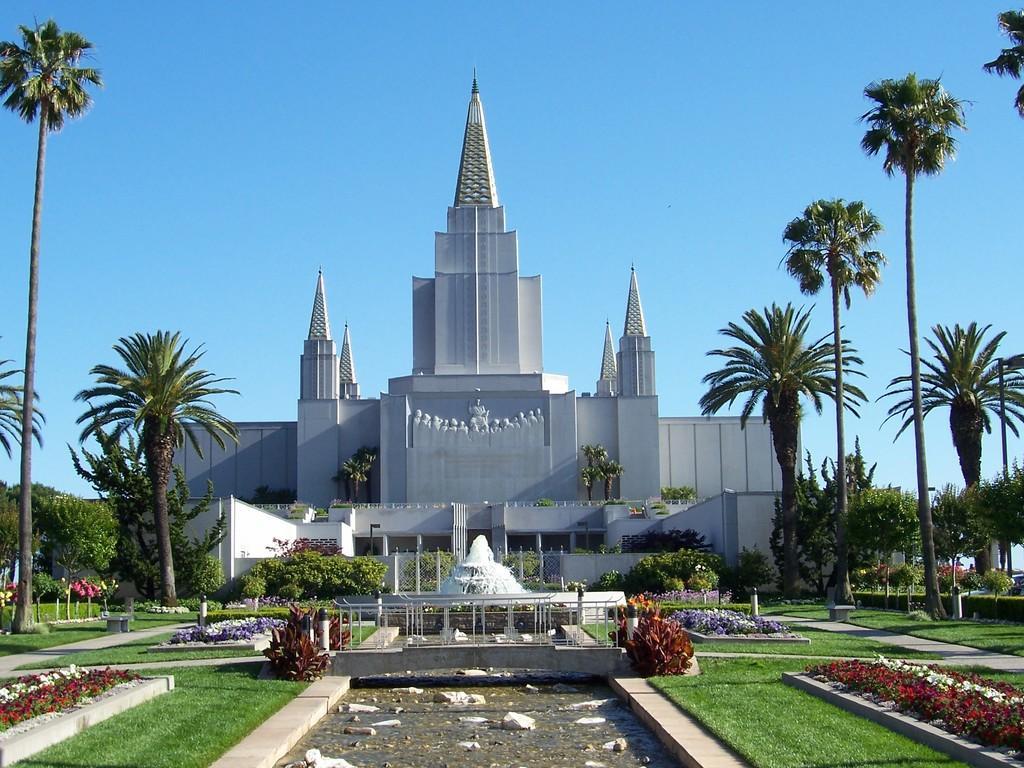Could you give a brief overview of what you see in this image? There is a building. In front of the building there is a fountain. Near to the building there are trees, grass lawn and flowering plants. In the background there is sky with clouds. 